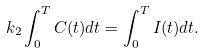Convert formula to latex. <formula><loc_0><loc_0><loc_500><loc_500>k _ { 2 } \int _ { 0 } ^ { T } C ( t ) d t = \int _ { 0 } ^ { T } I ( t ) d t .</formula> 